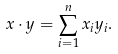<formula> <loc_0><loc_0><loc_500><loc_500>x \cdot y = \sum _ { i = 1 } ^ { n } x _ { i } y _ { i } .</formula> 